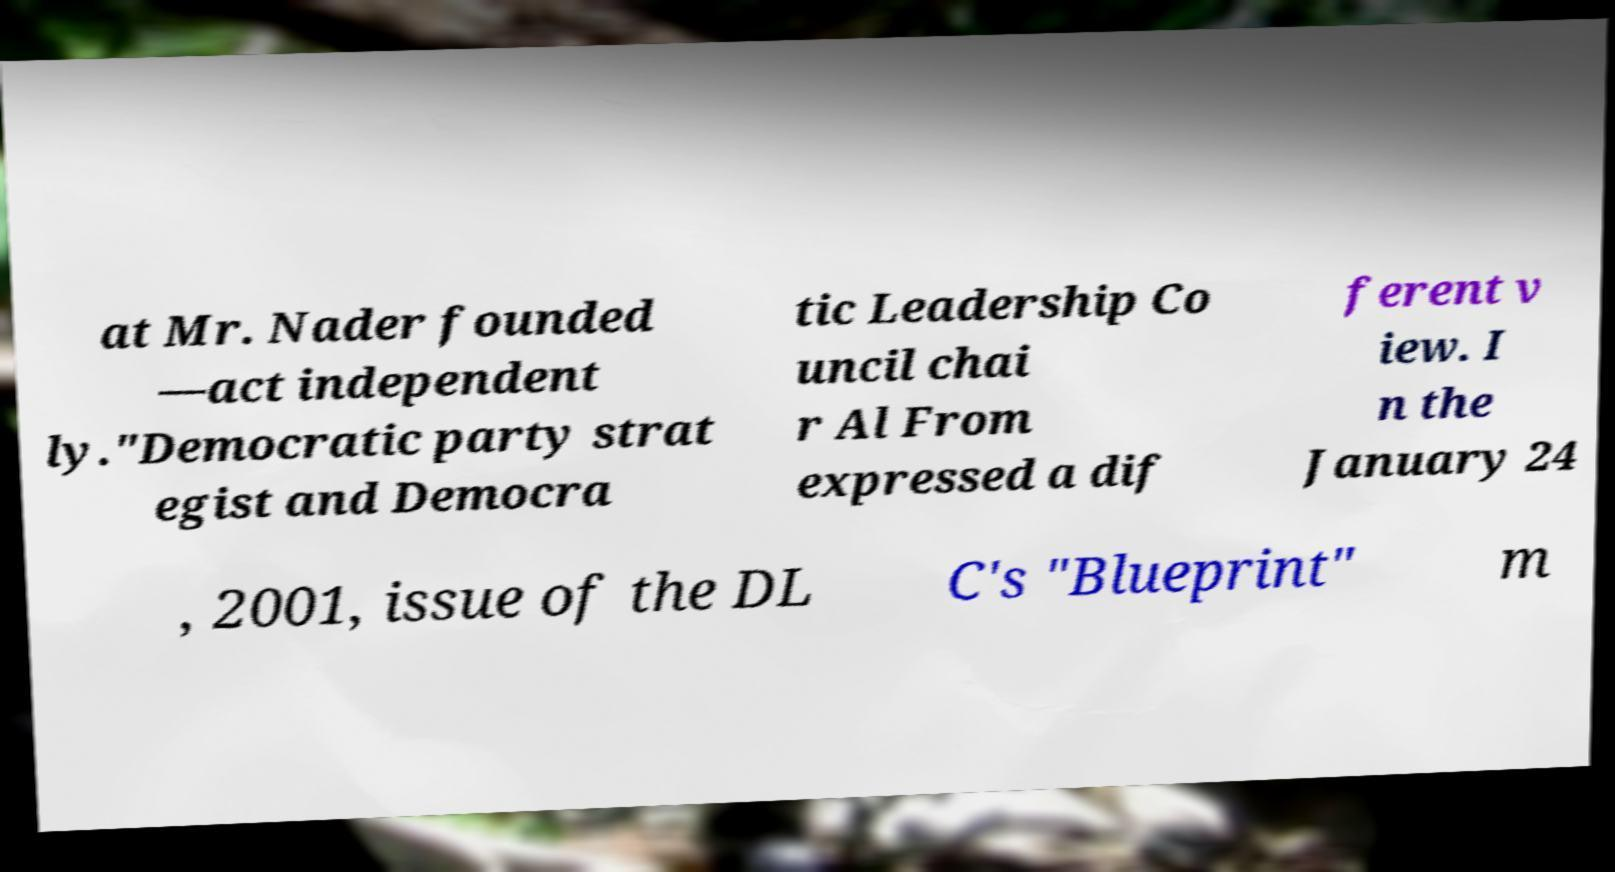Please identify and transcribe the text found in this image. at Mr. Nader founded —act independent ly."Democratic party strat egist and Democra tic Leadership Co uncil chai r Al From expressed a dif ferent v iew. I n the January 24 , 2001, issue of the DL C's "Blueprint" m 